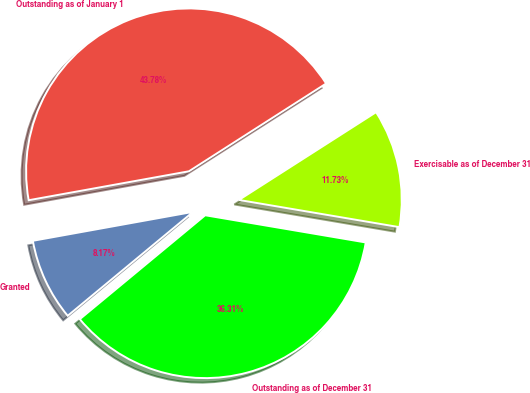Convert chart to OTSL. <chart><loc_0><loc_0><loc_500><loc_500><pie_chart><fcel>Outstanding as of January 1<fcel>Granted<fcel>Outstanding as of December 31<fcel>Exercisable as of December 31<nl><fcel>43.78%<fcel>8.17%<fcel>36.31%<fcel>11.73%<nl></chart> 